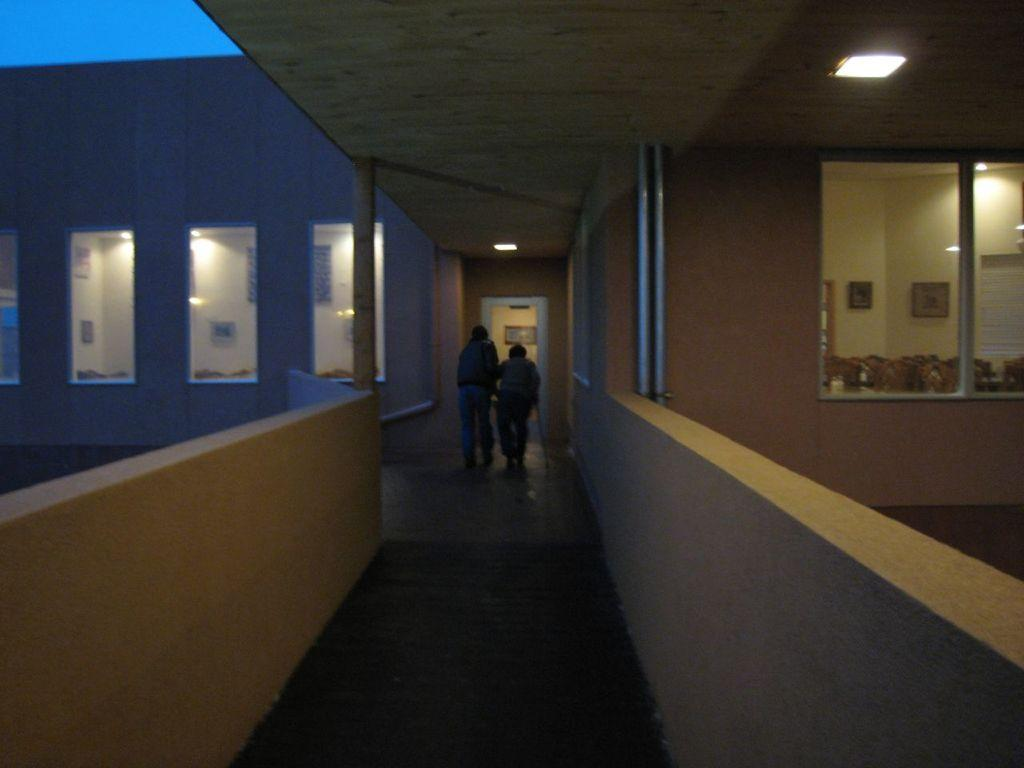What are the two people in the image doing? The two people in the image are walking. Where are the people walking? The people are walking in a corridor. What can be seen in the background of the image? There are rooms with glass windows in the image. What type of meat can be seen hanging from the ceiling in the image? There is no meat present in the image; it features two people walking in a corridor with rooms having glass windows in the background. 